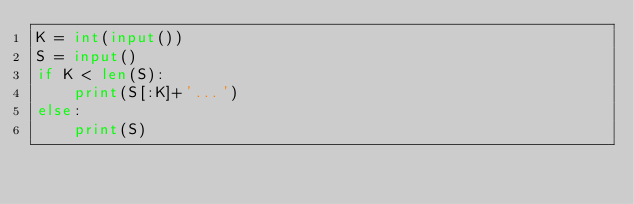<code> <loc_0><loc_0><loc_500><loc_500><_Python_>K = int(input())
S = input()
if K < len(S):
    print(S[:K]+'...')
else:
    print(S)</code> 